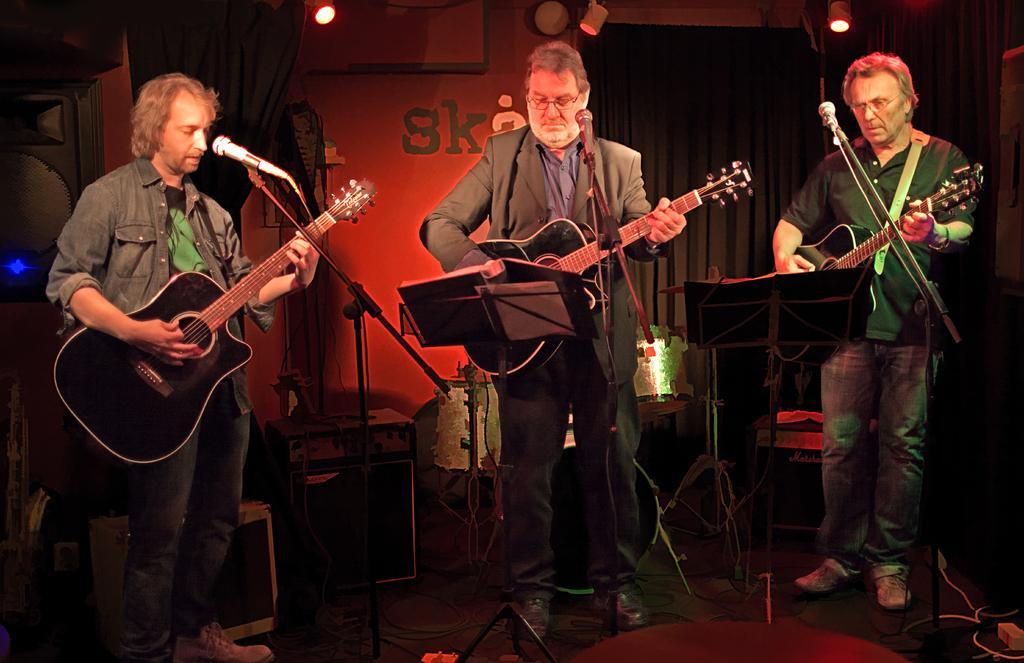Can you describe this image briefly? As we can see in he image there are curtains, three people standing on stage and holding guitar in their hands and singing song on mike. 